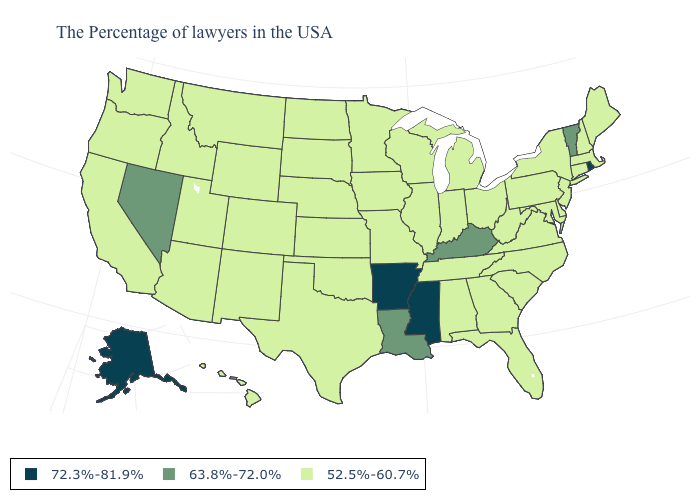Which states have the lowest value in the West?
Be succinct. Wyoming, Colorado, New Mexico, Utah, Montana, Arizona, Idaho, California, Washington, Oregon, Hawaii. What is the value of West Virginia?
Be succinct. 52.5%-60.7%. What is the lowest value in the USA?
Write a very short answer. 52.5%-60.7%. Name the states that have a value in the range 63.8%-72.0%?
Write a very short answer. Vermont, Kentucky, Louisiana, Nevada. How many symbols are there in the legend?
Quick response, please. 3. How many symbols are there in the legend?
Be succinct. 3. What is the lowest value in the West?
Concise answer only. 52.5%-60.7%. Name the states that have a value in the range 52.5%-60.7%?
Answer briefly. Maine, Massachusetts, New Hampshire, Connecticut, New York, New Jersey, Delaware, Maryland, Pennsylvania, Virginia, North Carolina, South Carolina, West Virginia, Ohio, Florida, Georgia, Michigan, Indiana, Alabama, Tennessee, Wisconsin, Illinois, Missouri, Minnesota, Iowa, Kansas, Nebraska, Oklahoma, Texas, South Dakota, North Dakota, Wyoming, Colorado, New Mexico, Utah, Montana, Arizona, Idaho, California, Washington, Oregon, Hawaii. Does Oregon have a lower value than North Dakota?
Answer briefly. No. How many symbols are there in the legend?
Write a very short answer. 3. Name the states that have a value in the range 52.5%-60.7%?
Keep it brief. Maine, Massachusetts, New Hampshire, Connecticut, New York, New Jersey, Delaware, Maryland, Pennsylvania, Virginia, North Carolina, South Carolina, West Virginia, Ohio, Florida, Georgia, Michigan, Indiana, Alabama, Tennessee, Wisconsin, Illinois, Missouri, Minnesota, Iowa, Kansas, Nebraska, Oklahoma, Texas, South Dakota, North Dakota, Wyoming, Colorado, New Mexico, Utah, Montana, Arizona, Idaho, California, Washington, Oregon, Hawaii. What is the value of Nebraska?
Keep it brief. 52.5%-60.7%. Does the first symbol in the legend represent the smallest category?
Answer briefly. No. What is the value of Maine?
Short answer required. 52.5%-60.7%. What is the value of New Hampshire?
Write a very short answer. 52.5%-60.7%. 